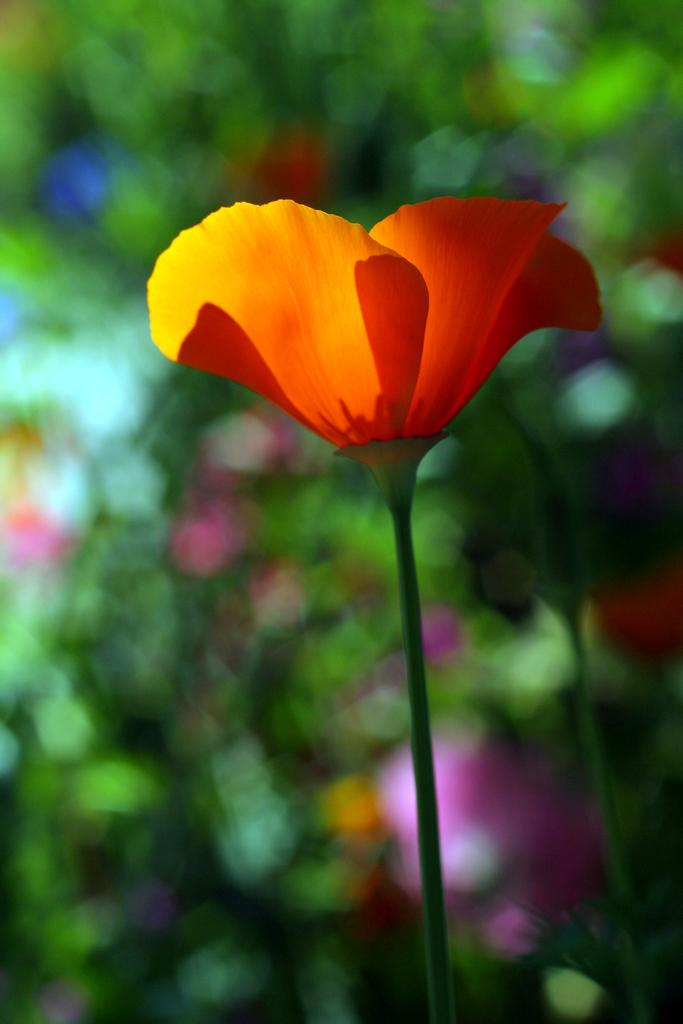What type of flower is the main subject of the image? There is an orange color flower in the image. Is the orange flower part of a larger plant? Yes, the orange flower is attached to a plant. What colors of flowers can be seen in the background of the image? In the background, there are pink, blue, yellow, and red color flowers on plants. How would you describe the background in terms of focus? The background is blurry. What type of list is hanging on the curtain in the image? There is no list or curtain present in the image; it features flowers and plants. 